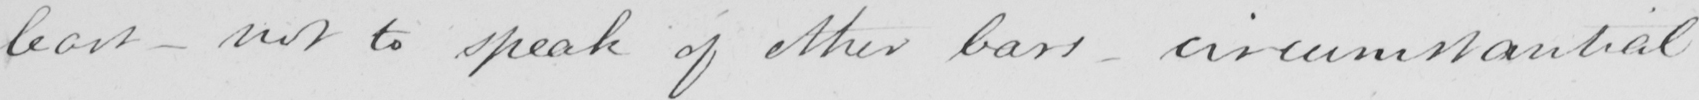What text is written in this handwritten line? least  _  not to speak of other bars  _  circumstantial 